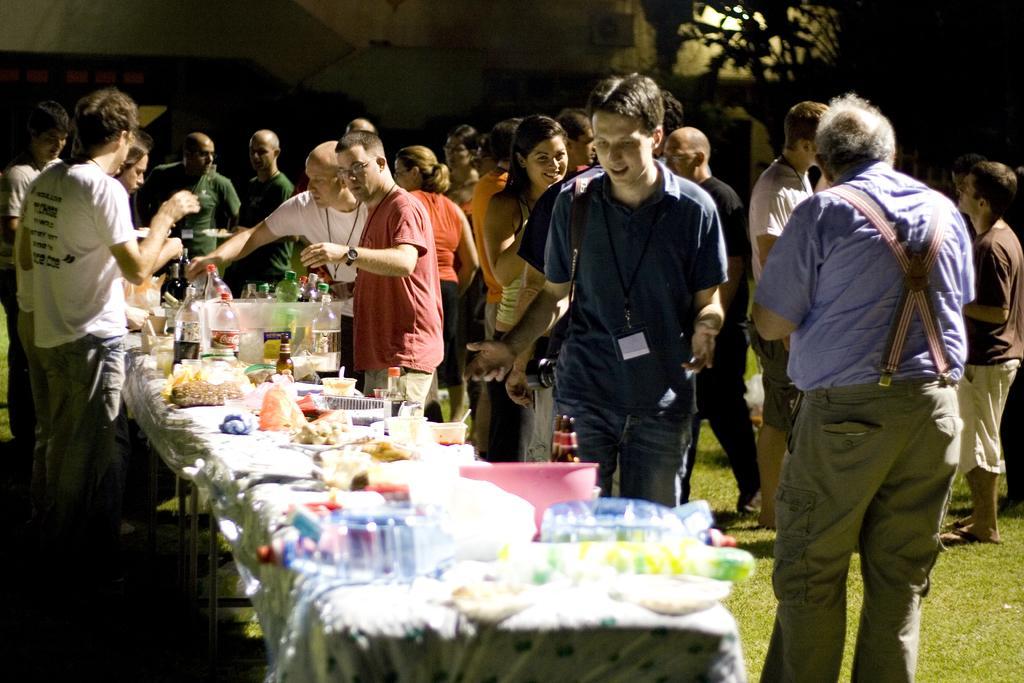How would you summarize this image in a sentence or two? In this image we can see a group of people are standing on the ground, in front here is the table, and food items n it, here are the bottles, and some objects on it, here is the tree. 